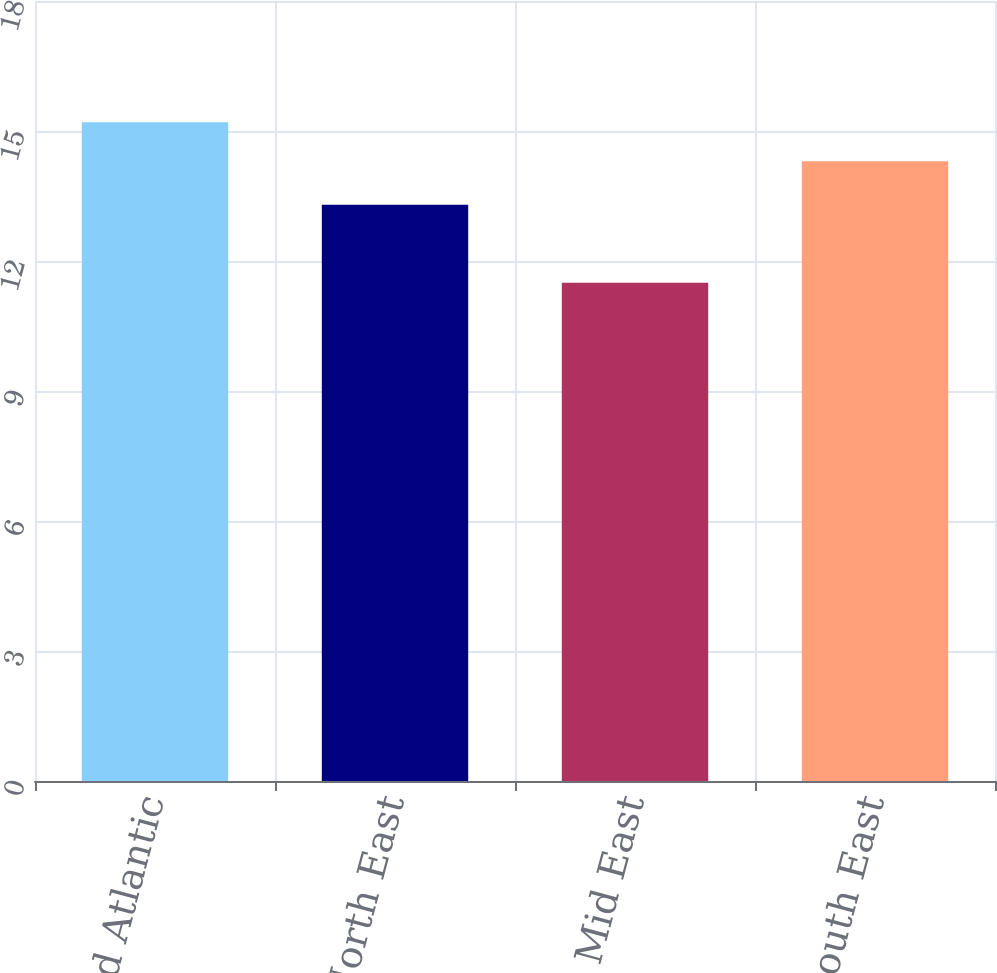Convert chart. <chart><loc_0><loc_0><loc_500><loc_500><bar_chart><fcel>Mid Atlantic<fcel>North East<fcel>Mid East<fcel>South East<nl><fcel>15.2<fcel>13.3<fcel>11.5<fcel>14.3<nl></chart> 